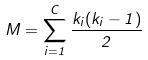Convert formula to latex. <formula><loc_0><loc_0><loc_500><loc_500>M = \sum _ { i = 1 } ^ { C } \frac { k _ { i } ( k _ { i } - 1 ) } { 2 }</formula> 